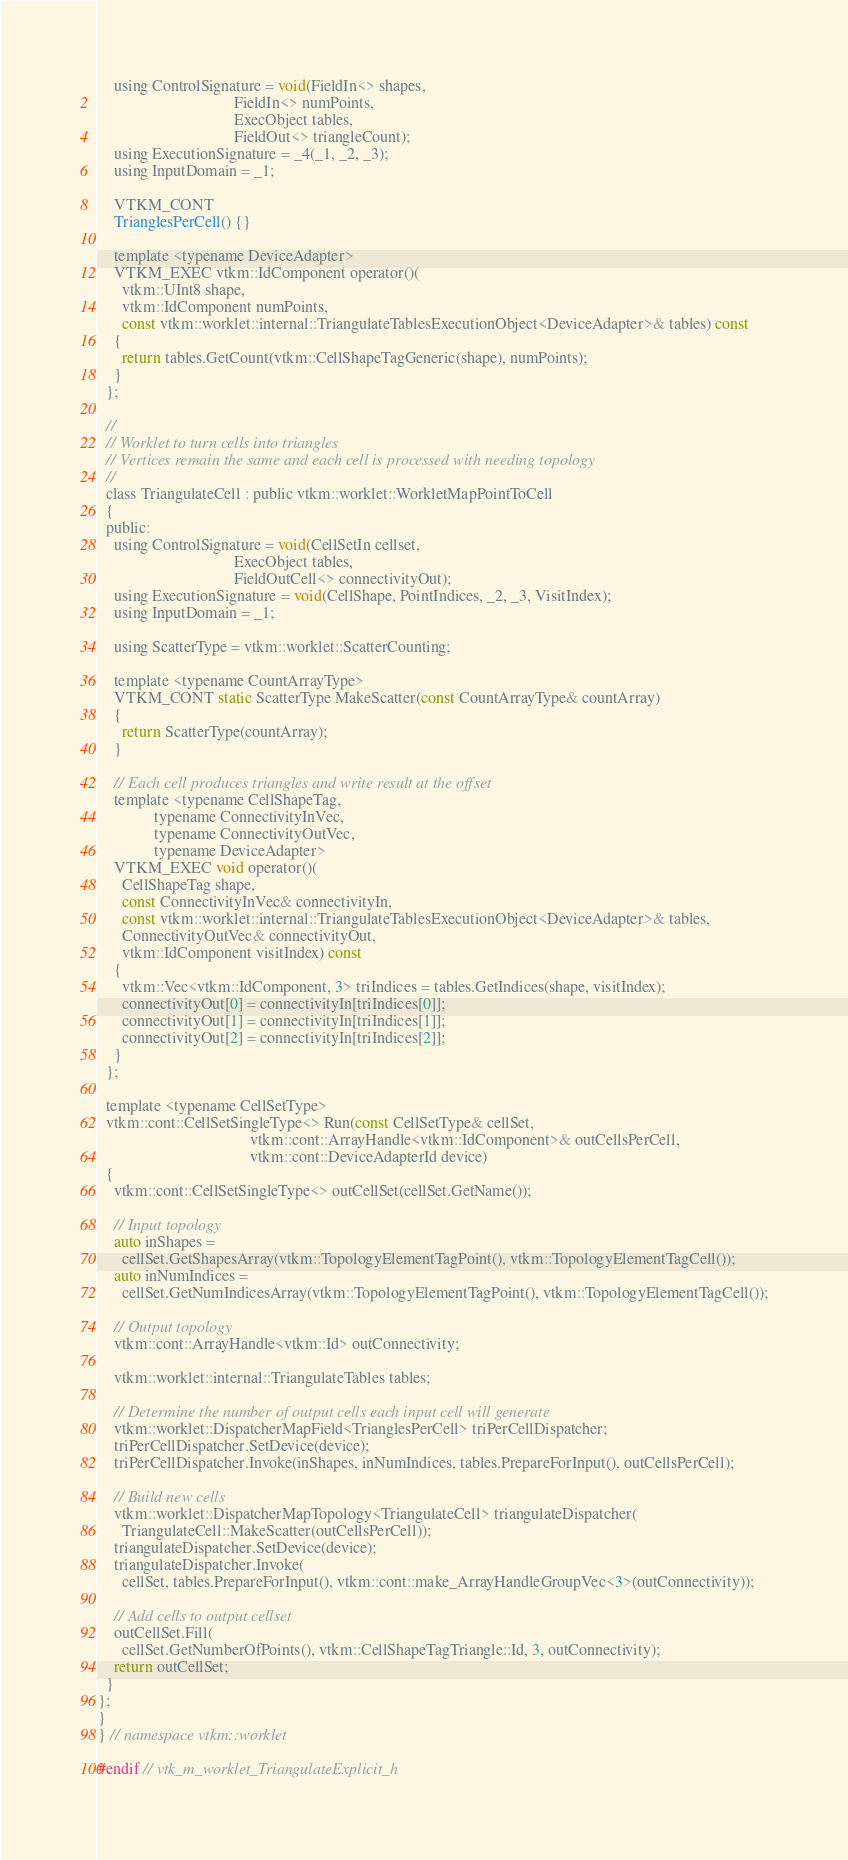Convert code to text. <code><loc_0><loc_0><loc_500><loc_500><_C_>    using ControlSignature = void(FieldIn<> shapes,
                                  FieldIn<> numPoints,
                                  ExecObject tables,
                                  FieldOut<> triangleCount);
    using ExecutionSignature = _4(_1, _2, _3);
    using InputDomain = _1;

    VTKM_CONT
    TrianglesPerCell() {}

    template <typename DeviceAdapter>
    VTKM_EXEC vtkm::IdComponent operator()(
      vtkm::UInt8 shape,
      vtkm::IdComponent numPoints,
      const vtkm::worklet::internal::TriangulateTablesExecutionObject<DeviceAdapter>& tables) const
    {
      return tables.GetCount(vtkm::CellShapeTagGeneric(shape), numPoints);
    }
  };

  //
  // Worklet to turn cells into triangles
  // Vertices remain the same and each cell is processed with needing topology
  //
  class TriangulateCell : public vtkm::worklet::WorkletMapPointToCell
  {
  public:
    using ControlSignature = void(CellSetIn cellset,
                                  ExecObject tables,
                                  FieldOutCell<> connectivityOut);
    using ExecutionSignature = void(CellShape, PointIndices, _2, _3, VisitIndex);
    using InputDomain = _1;

    using ScatterType = vtkm::worklet::ScatterCounting;

    template <typename CountArrayType>
    VTKM_CONT static ScatterType MakeScatter(const CountArrayType& countArray)
    {
      return ScatterType(countArray);
    }

    // Each cell produces triangles and write result at the offset
    template <typename CellShapeTag,
              typename ConnectivityInVec,
              typename ConnectivityOutVec,
              typename DeviceAdapter>
    VTKM_EXEC void operator()(
      CellShapeTag shape,
      const ConnectivityInVec& connectivityIn,
      const vtkm::worklet::internal::TriangulateTablesExecutionObject<DeviceAdapter>& tables,
      ConnectivityOutVec& connectivityOut,
      vtkm::IdComponent visitIndex) const
    {
      vtkm::Vec<vtkm::IdComponent, 3> triIndices = tables.GetIndices(shape, visitIndex);
      connectivityOut[0] = connectivityIn[triIndices[0]];
      connectivityOut[1] = connectivityIn[triIndices[1]];
      connectivityOut[2] = connectivityIn[triIndices[2]];
    }
  };

  template <typename CellSetType>
  vtkm::cont::CellSetSingleType<> Run(const CellSetType& cellSet,
                                      vtkm::cont::ArrayHandle<vtkm::IdComponent>& outCellsPerCell,
                                      vtkm::cont::DeviceAdapterId device)
  {
    vtkm::cont::CellSetSingleType<> outCellSet(cellSet.GetName());

    // Input topology
    auto inShapes =
      cellSet.GetShapesArray(vtkm::TopologyElementTagPoint(), vtkm::TopologyElementTagCell());
    auto inNumIndices =
      cellSet.GetNumIndicesArray(vtkm::TopologyElementTagPoint(), vtkm::TopologyElementTagCell());

    // Output topology
    vtkm::cont::ArrayHandle<vtkm::Id> outConnectivity;

    vtkm::worklet::internal::TriangulateTables tables;

    // Determine the number of output cells each input cell will generate
    vtkm::worklet::DispatcherMapField<TrianglesPerCell> triPerCellDispatcher;
    triPerCellDispatcher.SetDevice(device);
    triPerCellDispatcher.Invoke(inShapes, inNumIndices, tables.PrepareForInput(), outCellsPerCell);

    // Build new cells
    vtkm::worklet::DispatcherMapTopology<TriangulateCell> triangulateDispatcher(
      TriangulateCell::MakeScatter(outCellsPerCell));
    triangulateDispatcher.SetDevice(device);
    triangulateDispatcher.Invoke(
      cellSet, tables.PrepareForInput(), vtkm::cont::make_ArrayHandleGroupVec<3>(outConnectivity));

    // Add cells to output cellset
    outCellSet.Fill(
      cellSet.GetNumberOfPoints(), vtkm::CellShapeTagTriangle::Id, 3, outConnectivity);
    return outCellSet;
  }
};
}
} // namespace vtkm::worklet

#endif // vtk_m_worklet_TriangulateExplicit_h
</code> 